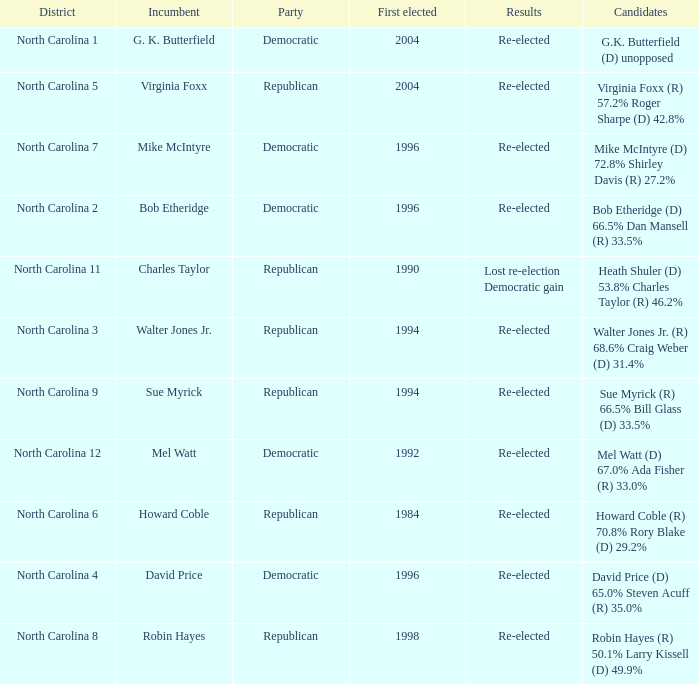How many times was Mike McIntyre elected? 1.0. 